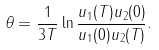Convert formula to latex. <formula><loc_0><loc_0><loc_500><loc_500>\theta = \frac { 1 } { 3 T } \ln \frac { u _ { 1 } ( T ) u _ { 2 } ( 0 ) } { u _ { 1 } ( 0 ) u _ { 2 } ( T ) } .</formula> 